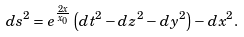<formula> <loc_0><loc_0><loc_500><loc_500>d s ^ { 2 } = e ^ { \frac { 2 x } { x _ { 0 } } } \left ( d t ^ { 2 } - d z ^ { 2 } - d y ^ { 2 } \right ) - d x ^ { 2 } .</formula> 